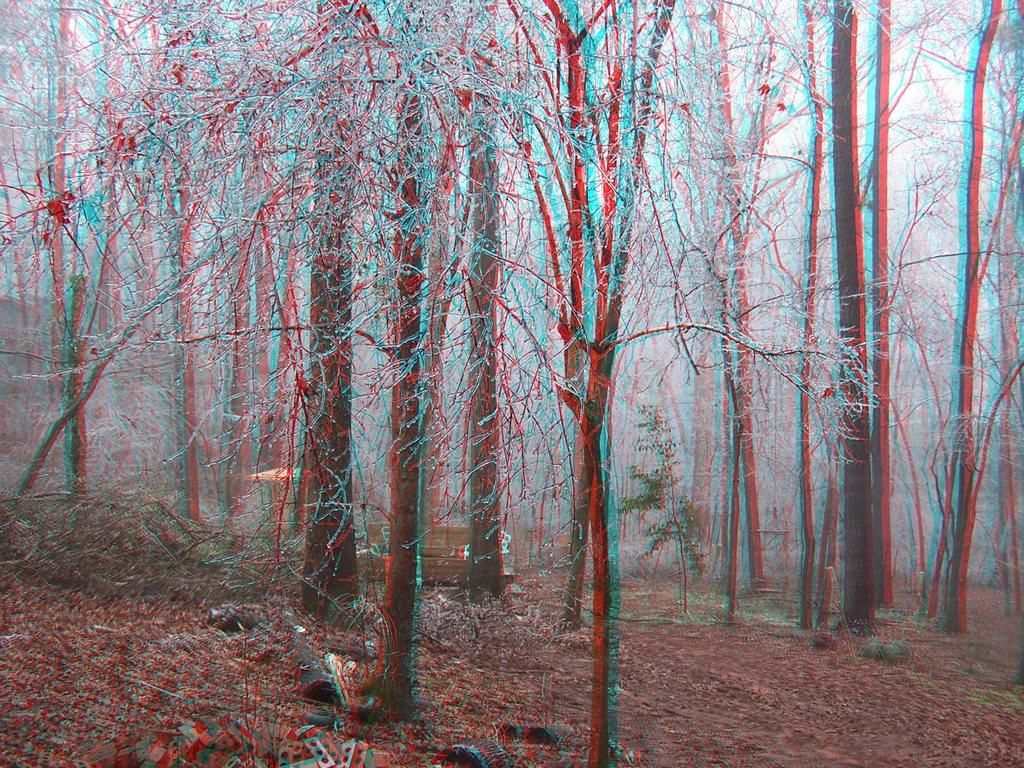What type of vegetation is present can be seen in the image? There are trees and plants in the image. Can you describe any objects in the background of the image? There appears to be a wooden box in the background of the image. Is there a woman resting on the wooden box in the image? There is no woman present in the image, nor is there any indication of someone resting on the wooden box. 